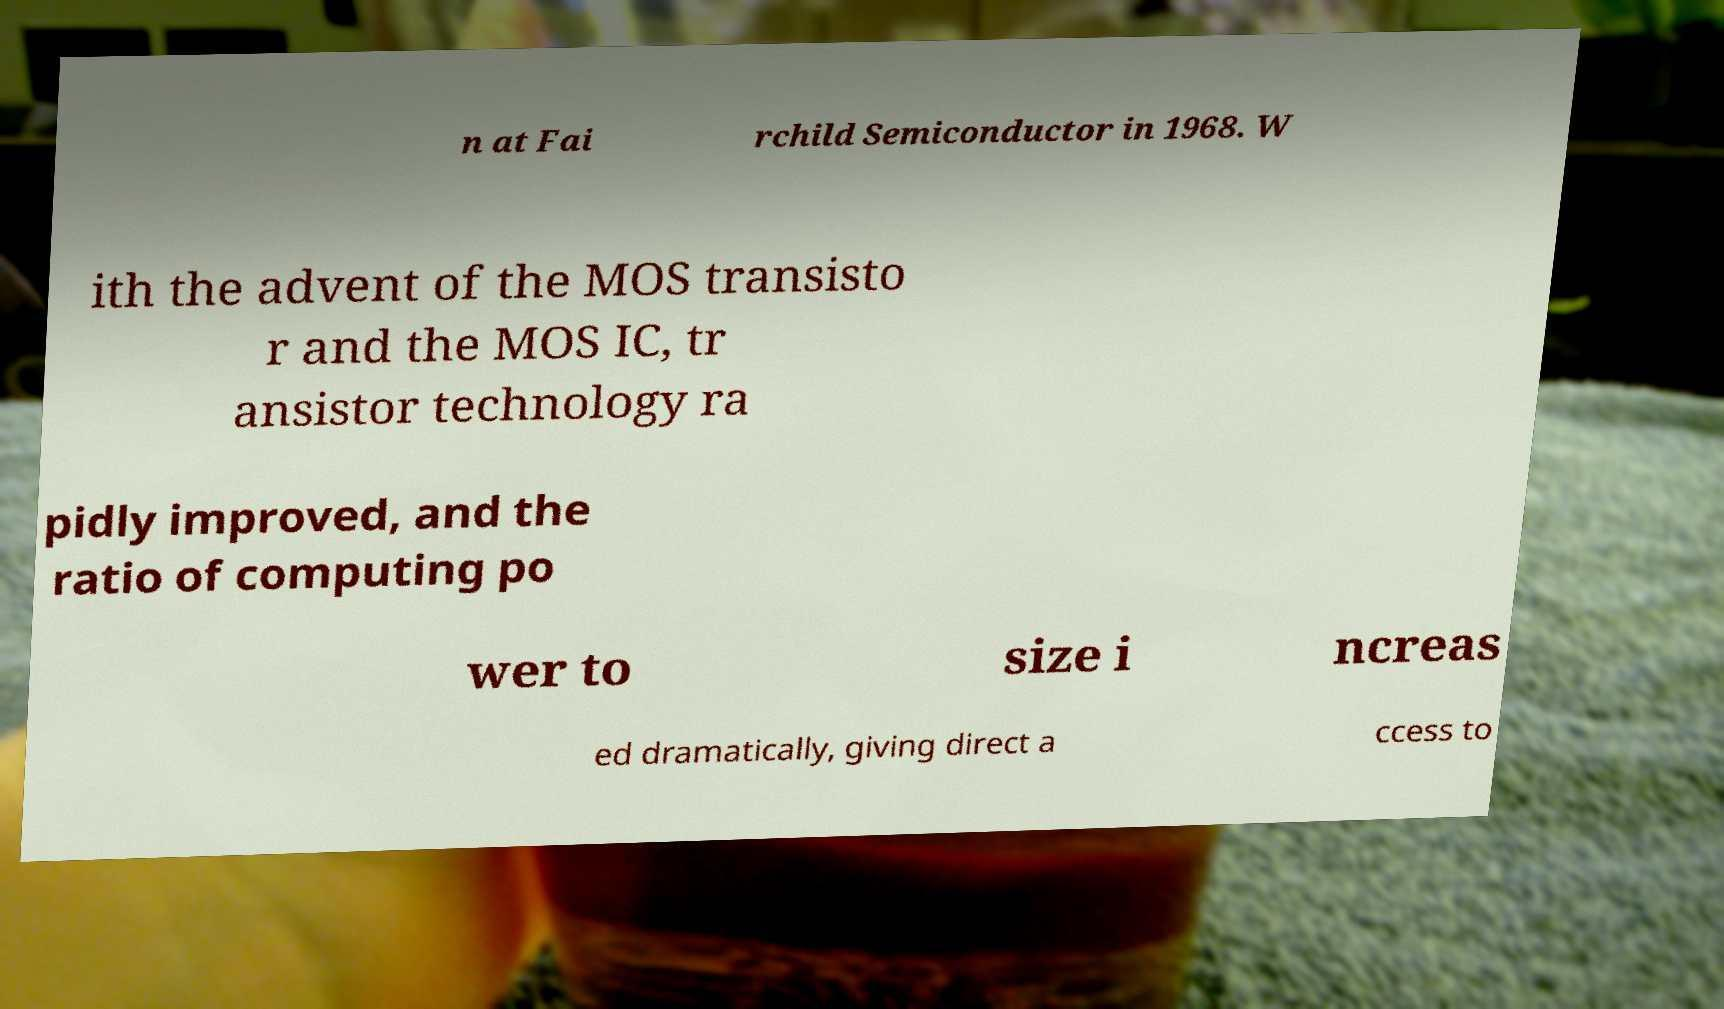What messages or text are displayed in this image? I need them in a readable, typed format. n at Fai rchild Semiconductor in 1968. W ith the advent of the MOS transisto r and the MOS IC, tr ansistor technology ra pidly improved, and the ratio of computing po wer to size i ncreas ed dramatically, giving direct a ccess to 